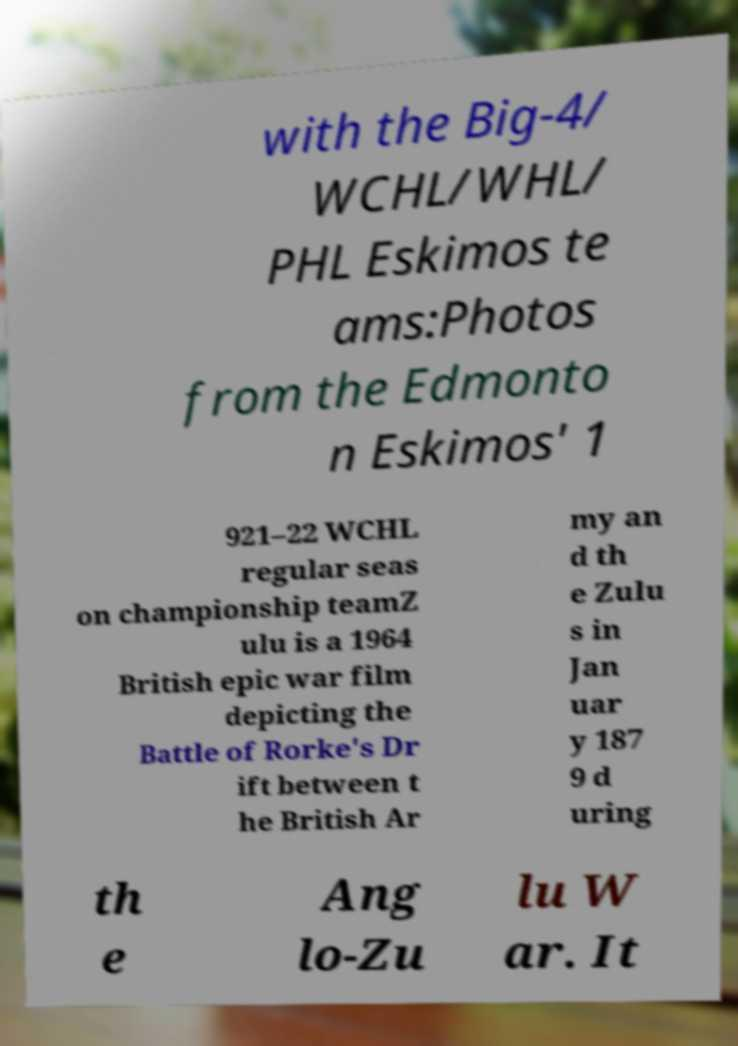Could you assist in decoding the text presented in this image and type it out clearly? with the Big-4/ WCHL/WHL/ PHL Eskimos te ams:Photos from the Edmonto n Eskimos' 1 921–22 WCHL regular seas on championship teamZ ulu is a 1964 British epic war film depicting the Battle of Rorke's Dr ift between t he British Ar my an d th e Zulu s in Jan uar y 187 9 d uring th e Ang lo-Zu lu W ar. It 